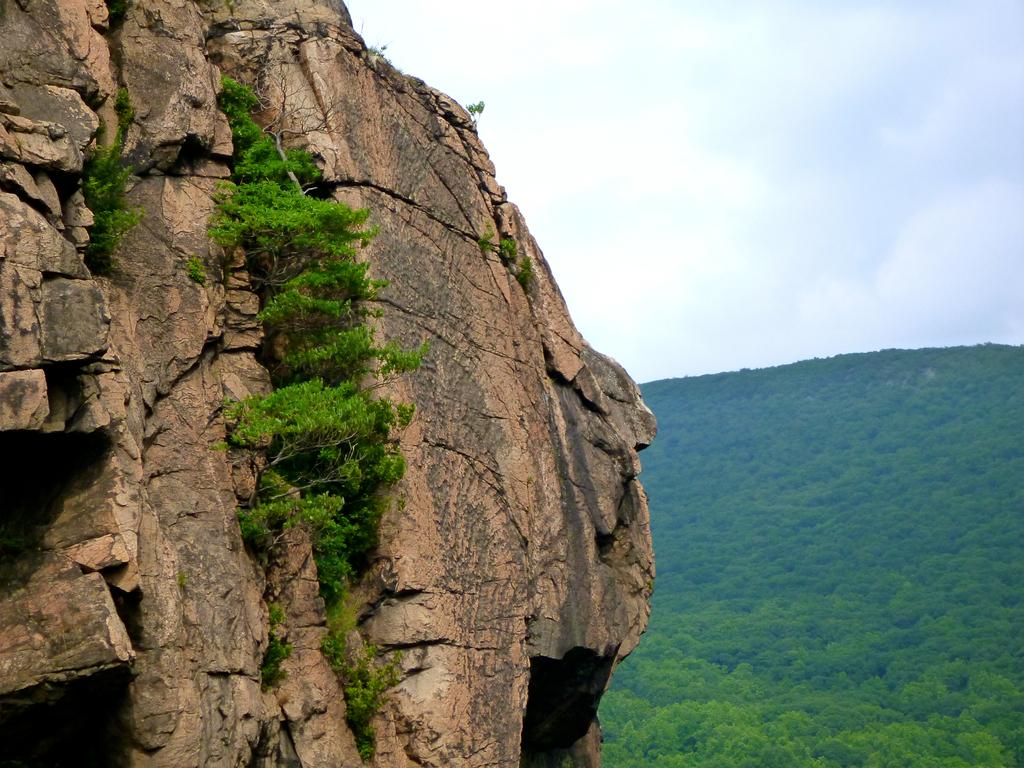What type of natural elements can be seen in the image? There are trees and hills visible in the image. What is visible in the background of the image? The sky is visible in the image. What can be observed in the sky? Clouds are present in the sky. Where is the office located in the image? There is no office present in the image; it features natural elements such as trees, hills, and the sky. 